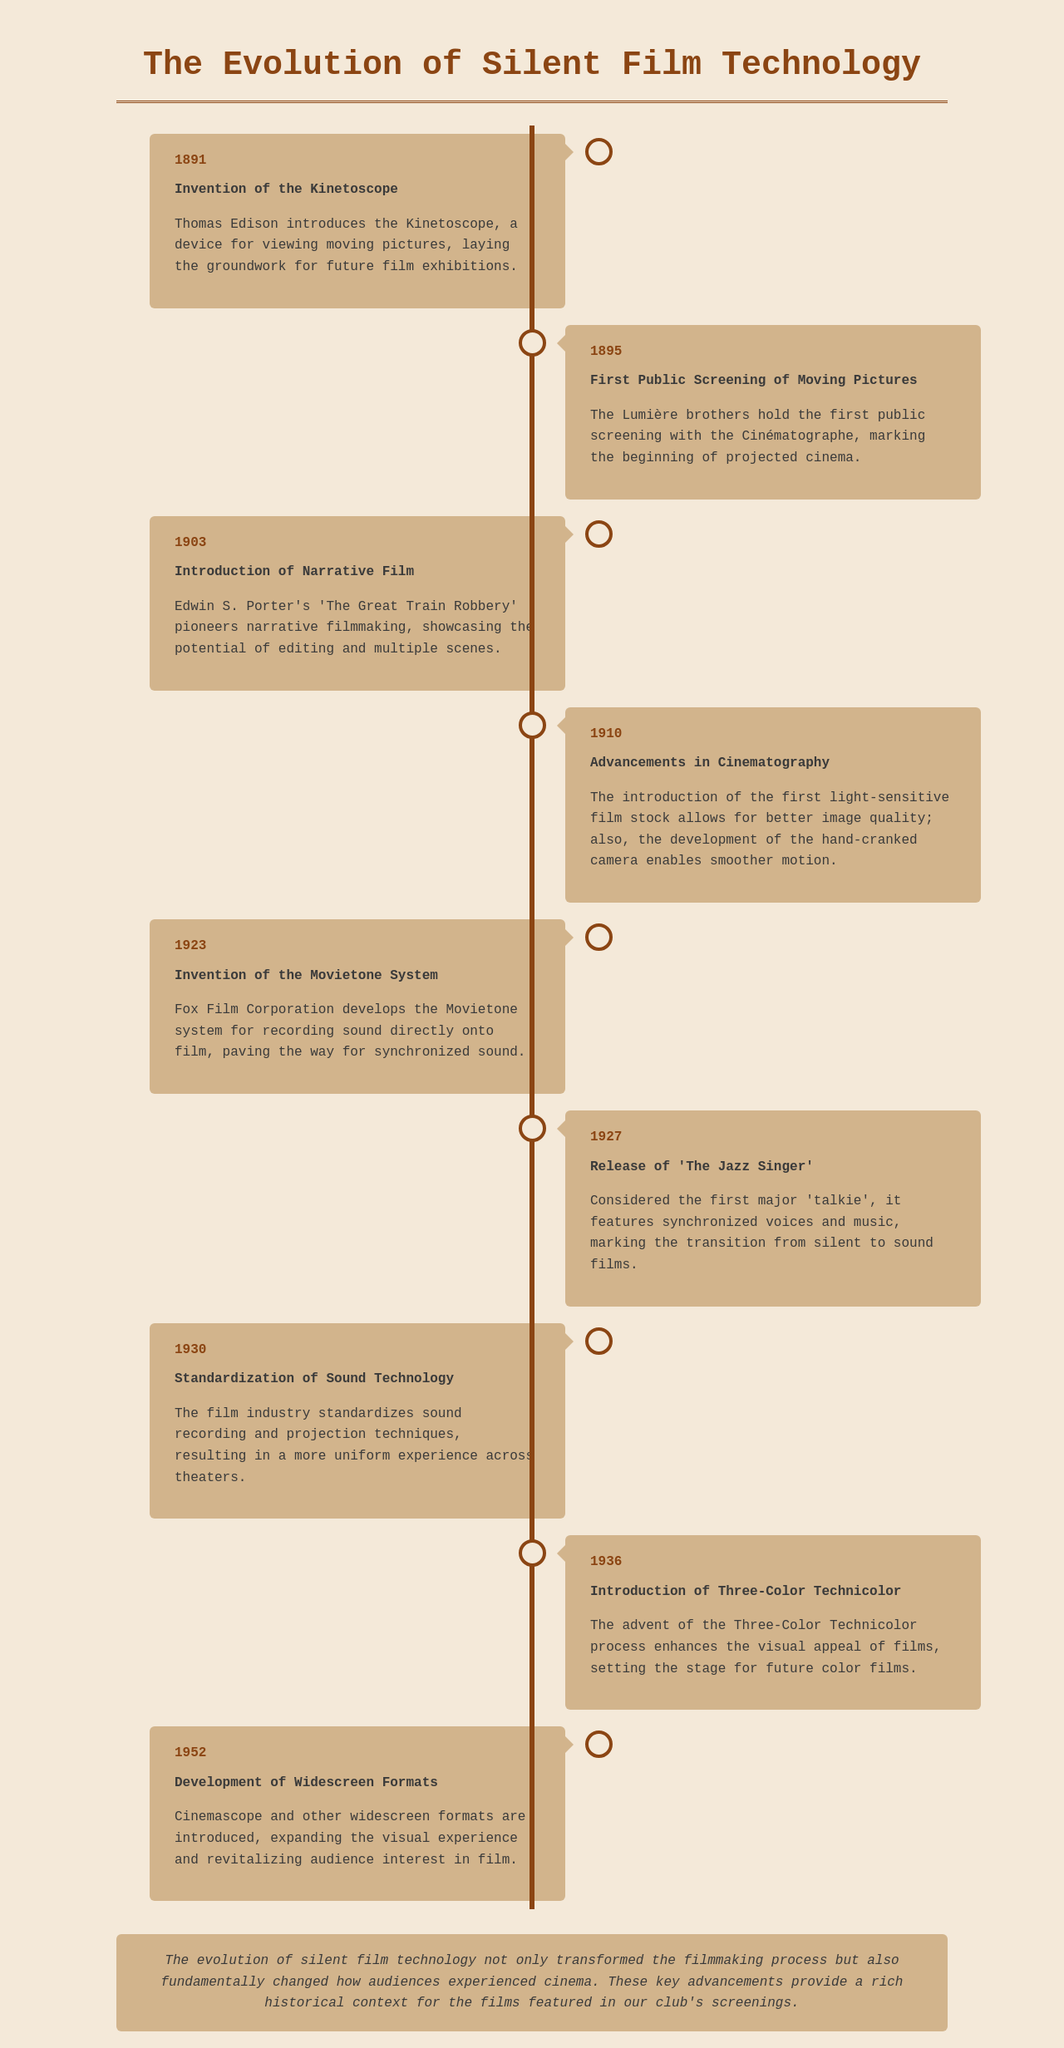What year was the Kinetoscope invented? The Kinetoscope was invented in 1891, as indicated in the timeline.
Answer: 1891 What significant event occurred in 1927? In 1927, 'The Jazz Singer' was released, marking a major development in film technology.
Answer: 'The Jazz Singer' Which system was developed by Fox Film Corporation in 1923? The Movietone system was developed in 1923, as noted in the timeline.
Answer: Movietone system What was the primary advancement in cinematography noted in 1910? The introduction of the first light-sensitive film stock allowed for better image quality.
Answer: Light-sensitive film stock How many key events are listed in the timeline? The timeline includes a total of eight key events related to silent film technology.
Answer: Eight What was the main impact of the 1930 standardization? The standardization of sound technology resulted in a more uniform experience across theaters.
Answer: Uniform experience What marked the transition from silent to sound films? The release of 'The Jazz Singer' in 1927 featured synchronized voices and music, marking this transition.
Answer: Synchronized voices and music Which technological advancement was introduced in 1952? The development of widescreen formats, including Cinemascope, was introduced in 1952.
Answer: Widescreen formats What year saw the introduction of Three-Color Technicolor? The introduction of Three-Color Technicolor occurred in 1936, as stated in the document.
Answer: 1936 